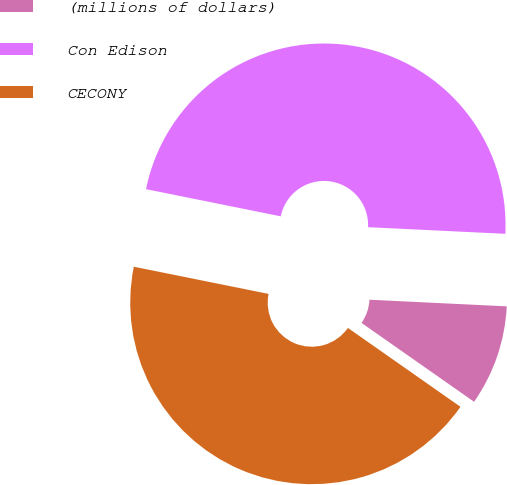<chart> <loc_0><loc_0><loc_500><loc_500><pie_chart><fcel>(millions of dollars)<fcel>Con Edison<fcel>CECONY<nl><fcel>8.96%<fcel>47.6%<fcel>43.44%<nl></chart> 